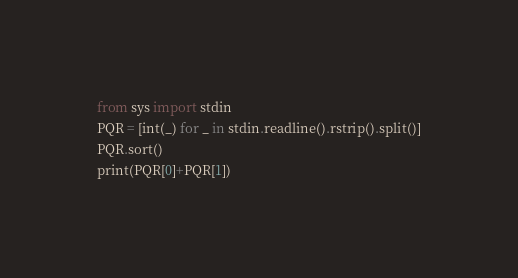Convert code to text. <code><loc_0><loc_0><loc_500><loc_500><_Python_>from sys import stdin
PQR = [int(_) for _ in stdin.readline().rstrip().split()]
PQR.sort()
print(PQR[0]+PQR[1])</code> 